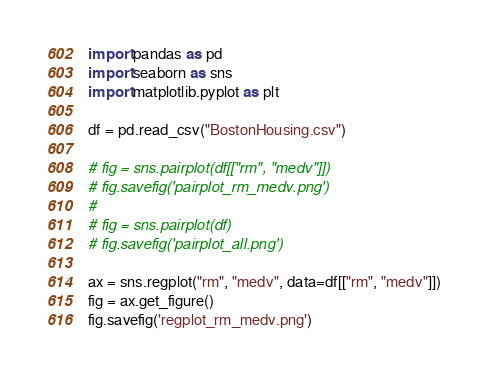Convert code to text. <code><loc_0><loc_0><loc_500><loc_500><_Python_>import pandas as pd
import seaborn as sns
import matplotlib.pyplot as plt

df = pd.read_csv("BostonHousing.csv")

# fig = sns.pairplot(df[["rm", "medv"]])
# fig.savefig('pairplot_rm_medv.png')
#
# fig = sns.pairplot(df)
# fig.savefig('pairplot_all.png')

ax = sns.regplot("rm", "medv", data=df[["rm", "medv"]])
fig = ax.get_figure()
fig.savefig('regplot_rm_medv.png')
</code> 